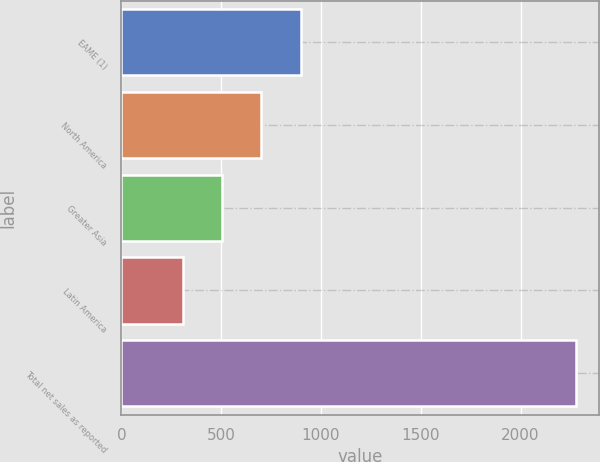Convert chart to OTSL. <chart><loc_0><loc_0><loc_500><loc_500><bar_chart><fcel>EAME (1)<fcel>North America<fcel>Greater Asia<fcel>Latin America<fcel>Total net sales as reported<nl><fcel>897.3<fcel>700.2<fcel>503.1<fcel>306<fcel>2277<nl></chart> 